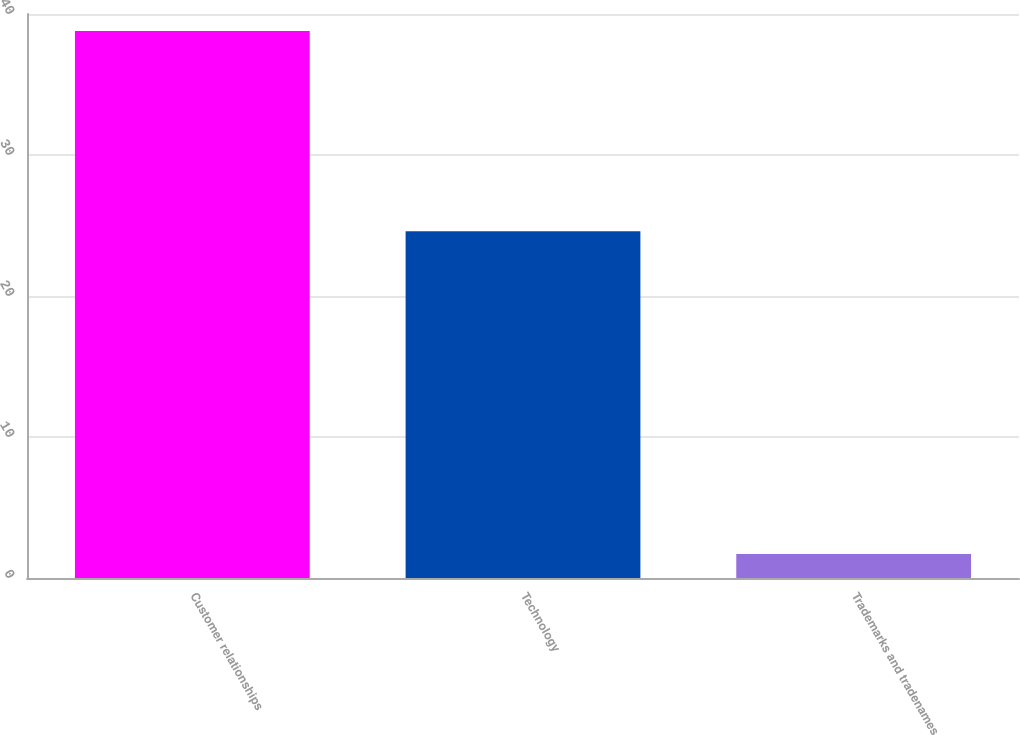<chart> <loc_0><loc_0><loc_500><loc_500><bar_chart><fcel>Customer relationships<fcel>Technology<fcel>Trademarks and tradenames<nl><fcel>38.8<fcel>24.6<fcel>1.7<nl></chart> 